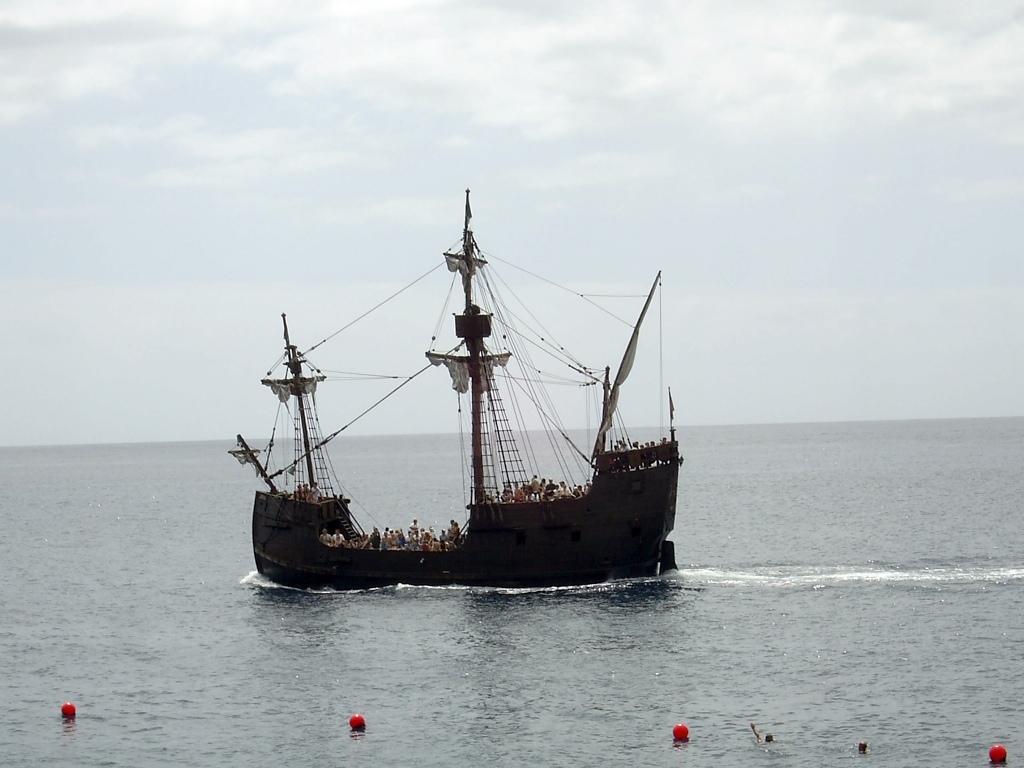Please provide a concise description of this image. In the center of the image there is a ship on the surface of the sea and there are people in the ship. In the background there is a cloudy sky. Image also consists of red color balls. 